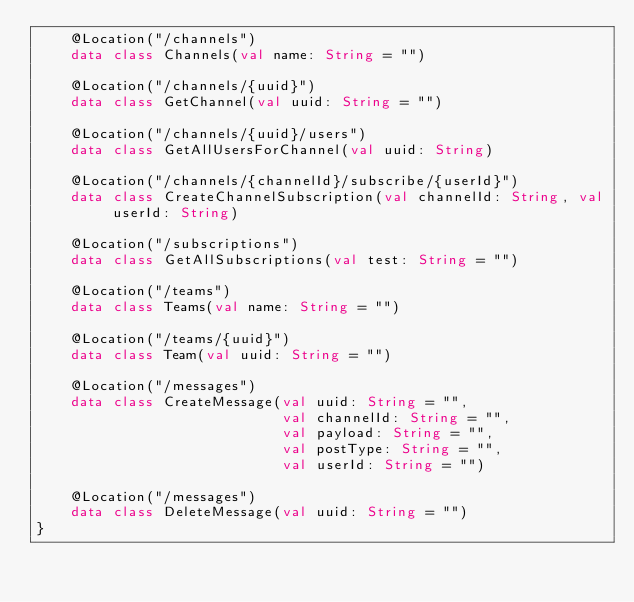Convert code to text. <code><loc_0><loc_0><loc_500><loc_500><_Kotlin_>    @Location("/channels")
    data class Channels(val name: String = "")

    @Location("/channels/{uuid}")
    data class GetChannel(val uuid: String = "")

    @Location("/channels/{uuid}/users")
    data class GetAllUsersForChannel(val uuid: String)

    @Location("/channels/{channelId}/subscribe/{userId}")
    data class CreateChannelSubscription(val channelId: String, val userId: String)

    @Location("/subscriptions")
    data class GetAllSubscriptions(val test: String = "")

    @Location("/teams")
    data class Teams(val name: String = "")

    @Location("/teams/{uuid}")
    data class Team(val uuid: String = "")

    @Location("/messages")
    data class CreateMessage(val uuid: String = "",
                             val channelId: String = "",
                             val payload: String = "",
                             val postType: String = "",
                             val userId: String = "")

    @Location("/messages")
    data class DeleteMessage(val uuid: String = "")
}</code> 